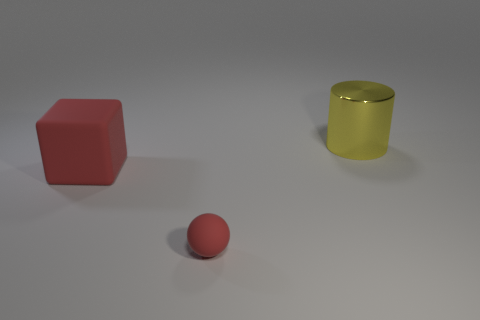Add 2 small green shiny objects. How many objects exist? 5 Subtract all cylinders. How many objects are left? 2 Subtract all red rubber cubes. Subtract all large red rubber things. How many objects are left? 1 Add 1 red matte balls. How many red matte balls are left? 2 Add 1 small cyan matte spheres. How many small cyan matte spheres exist? 1 Subtract 0 red cylinders. How many objects are left? 3 